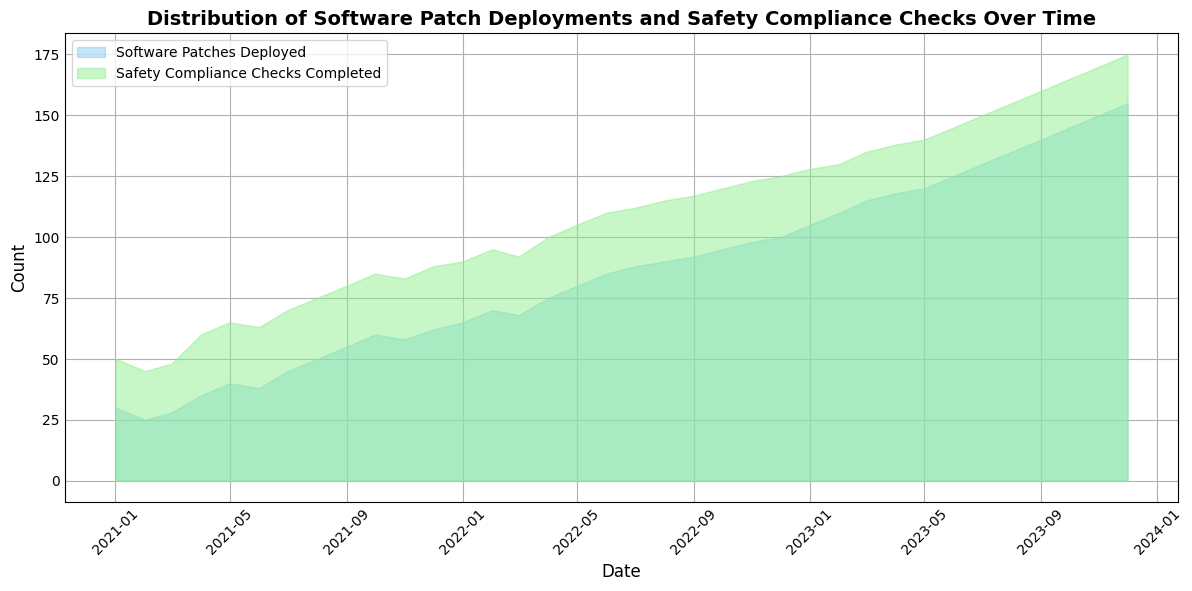How does the number of Software Patches Deployed compare to the number of Safety Compliance Checks Completed in March 2022? In March 2022, the number of Software Patches Deployed is 68, and the number of Safety Compliance Checks Completed is 92. By comparing these two numbers directly, we can see that the number of Safety Compliance Checks Completed is higher than the number of Software Patches Deployed.
Answer: The number of Safety Compliance Checks Completed is higher Which month shows the greatest increase in Software Patches Deployed, and how many patches were deployed that month? To find the month with the greatest increase, we can look at the differences between consecutive months for Software Patches Deployed. The largest increase is between December 2022 and January 2023, where it goes from 100 to 105 patches. So, January 2023 shows the greatest increase with 105 patches deployed.
Answer: January 2023 with 105 patches What is the average number of Safety Compliance Checks Completed in the first six months of 2022? To calculate the average, sum the number of Safety Compliance Checks Completed from January to June 2022 and divide by 6. The total is 90 + 95 + 92 + 100 + 105 + 110 = 592. The average is 592 / 6 = 98.67.
Answer: 98.67 In which month does the number of Software Patches Deployed and Safety Compliance Checks Completed first reach triple digits? We need to find the first month where both values are 100 or more. Software Patches Deployed reaches 100 in December 2022 and Safety Compliance Checks Completed reaches 100 in April 2022. Since both conditions must be met simultaneously, December 2022 is the correct month.
Answer: December 2022 How do the visual representations of Software Patches Deployed and Safety Compliance Checks Completed differ visually in October 2023, and what does this indicate? In October 2023, the area representing Software Patches Deployed is smaller than the area for Safety Compliance Checks Completed. Specifically, Software Patches Deployed is 145, while Safety Compliance Checks Completed is 165. The green color area (Safety Compliance Checks) is taller, indicating a larger count.
Answer: Safety Compliance Checks Completed is larger What is the difference between the highest and lowest monthly counts of Safety Compliance Checks Completed within the data range? The highest count of Safety Compliance Checks Completed is 175 (December 2023), and the lowest is 45 (February 2021). The difference is 175 - 45 = 130.
Answer: 130 